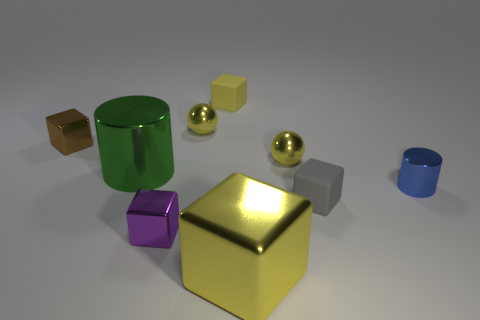Subtract 1 cubes. How many cubes are left? 4 Subtract all large yellow metal blocks. How many blocks are left? 4 Subtract all brown blocks. How many blocks are left? 4 Subtract all cyan cubes. Subtract all brown balls. How many cubes are left? 5 Subtract all cubes. How many objects are left? 4 Subtract all large yellow objects. Subtract all yellow things. How many objects are left? 4 Add 7 tiny purple shiny blocks. How many tiny purple shiny blocks are left? 8 Add 9 big purple metallic blocks. How many big purple metallic blocks exist? 9 Subtract 1 green cylinders. How many objects are left? 8 